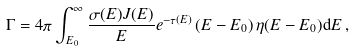<formula> <loc_0><loc_0><loc_500><loc_500>\Gamma = 4 \pi \int _ { E _ { 0 } } ^ { \infty } \frac { \sigma ( E ) J ( E ) } { E } e ^ { - \tau ( E ) } \left ( E - E _ { 0 } \right ) \eta ( E - E _ { 0 } ) \mathrm d E \, ,</formula> 